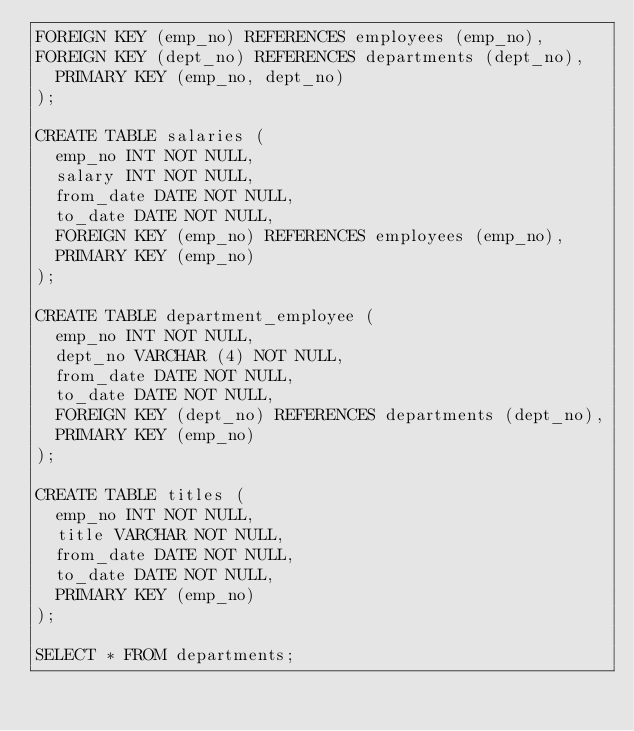Convert code to text. <code><loc_0><loc_0><loc_500><loc_500><_SQL_>FOREIGN KEY (emp_no) REFERENCES employees (emp_no),
FOREIGN KEY (dept_no) REFERENCES departments (dept_no),
	PRIMARY KEY (emp_no, dept_no)
);

CREATE TABLE salaries (
	emp_no INT NOT NULL,
	salary INT NOT NULL,
	from_date DATE NOT NULL,
	to_date DATE NOT NULL,
	FOREIGN KEY (emp_no) REFERENCES employees (emp_no),
	PRIMARY KEY (emp_no)
);

CREATE TABLE department_employee (
	emp_no INT NOT NULL,
	dept_no VARCHAR (4) NOT NULL,
	from_date DATE NOT NULL,
	to_date DATE NOT NULL,
	FOREIGN KEY (dept_no) REFERENCES departments (dept_no),
	PRIMARY KEY (emp_no)
);

CREATE TABLE titles (
	emp_no INT NOT NULL,
	title VARCHAR NOT NULL,
	from_date DATE NOT NULL,
	to_date DATE NOT NULL,
	PRIMARY KEY (emp_no)
);

SELECT * FROM departments;</code> 